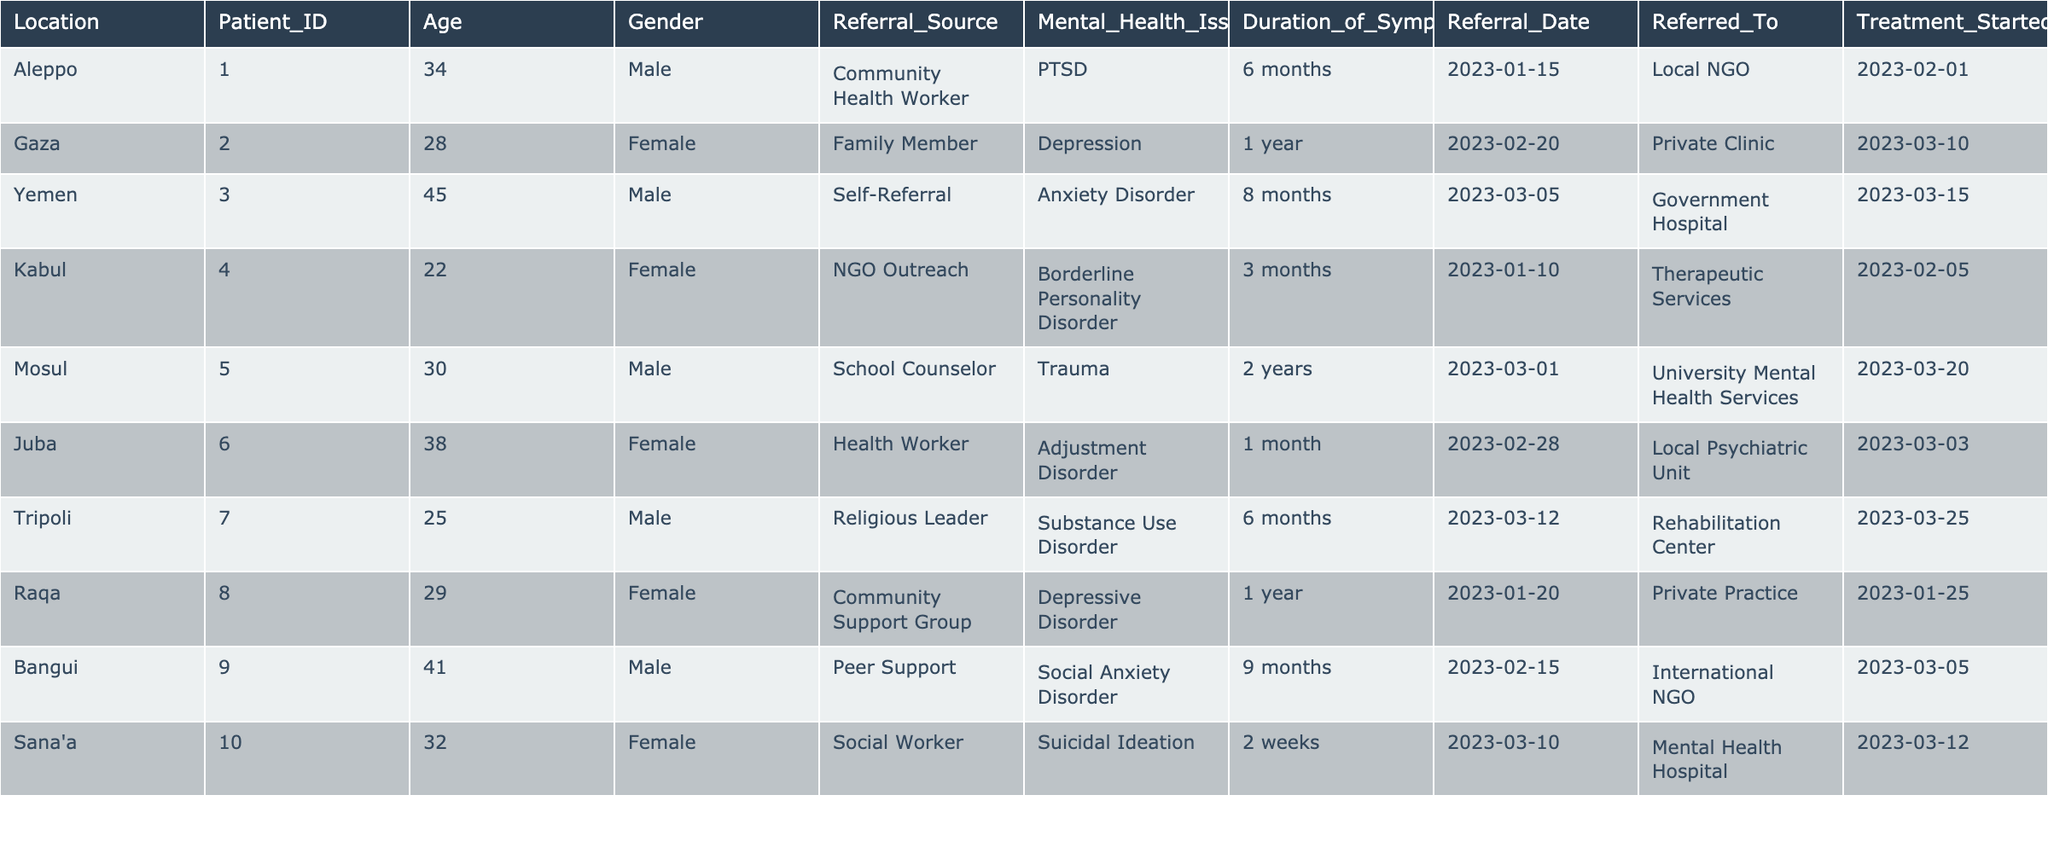What is the most common mental health issue reported by patients in this table? The table lists several mental health issues, and by examining the "Mental Health Issue" column, we see that PTSD, Depression, Anxiety Disorder, Borderline Personality Disorder, Trauma, Adjustment Disorder, Substance Use Disorder, Depressive Disorder, Social Anxiety Disorder, and Suicidal Ideation are mentioned. "Depression" appears twice (in Gaza and Raqa), while others appear only once, so it is the most common issue.
Answer: Depression How many patients referred themselves for treatment? By reviewing the "Referral Source" column, I can identify which patients self-referred. Only one patient (Patient ID 003 from Yemen) has "Self-Referral" listed as their referral source.
Answer: 1 What is the average age of patients in this table? To calculate the average age, I add the ages of all patients: 34, 28, 45, 22, 30, 38, 25, 29, 41, and 32, which sum to  34 + 28 + 45 + 22 + 30 + 38 + 25 + 29 + 41 + 32 =  354. There are 10 patients, so I divide 354 by 10 to get 35.4.
Answer: 35.4 Is there any patient who started treatment within two weeks after their referral date? By reviewing the "Referral Date" and "Treatment Started" columns, I see that only Sana'a patient (ID 010) has "Treatment Started" on 2023-03-12, just two days after being referred on 2023-03-10.
Answer: Yes What is the difference in the duration of symptoms between the youngest and oldest patient in this table? The youngest patient is Kabul (ID 004, age 22, symptoms duration 3 months) and the oldest patient is Yemen (ID 003, age 45, symptoms duration 8 months). The difference in symptom duration is 8 months - 3 months = 5 months.
Answer: 5 months What percentage of patients were referred by community sources? There are 10 patients in the table, and 2 were referred by community sources (Aleppo by Community Health Worker and Raqa by Community Support Group). To find the percentage, I divide 2 by 10 and multiply by 100, resulting in 20%.
Answer: 20% What is the total number of patients referred to local services compared to private services? Reviewing the "Referred To" column, I see that 5 patients were referred to local services (Local NGO, Local Psychiatric Unit, and Therapeutic Services), while 4 were referred to private services (Private Clinic, Private Practice, and Rehabilitation Center). Local services = 5, Private services = 4.
Answer: Local: 5, Private: 4 Which gender had more patients referred for treatment? By counting the number of male (5 patients) and female patients (5 patients), I find they are equal. The gender counts are equal, leading to a conclusion that there is no predominant gender in referrals.
Answer: Neither How many months of symptoms did the patient referred for Substance Use Disorder experience before starting treatment? The patient with Substance Use Disorder (ID 007) had 6 months of symptoms as per the "Duration of Symptoms" column. Thus, the answer is 6 months.
Answer: 6 months Which referral source appears to have the longest average duration of symptoms among their referred patients? I calculate the average duration of symptoms for each referral source. Community Health Worker (6 months), Family Member (12 months), Self-Referral (8 months), NGO Outreach (3 months), School Counselor (24 months), Health Worker (1 month), Religious Leader (6 months), Community Support Group (12 months), Peer Support (9 months), and Social Worker (2 weeks ~ 0.5 months). The total durations give School Counselor the highest average at 24 months.
Answer: School Counselor 